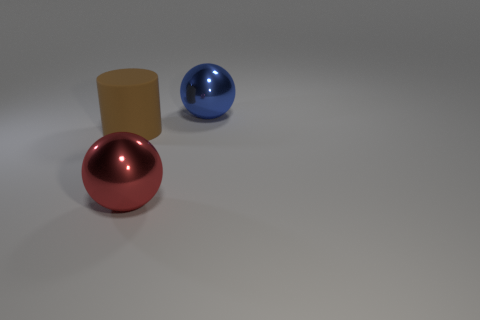Is there a rubber object of the same shape as the big blue metal object?
Give a very brief answer. No. What is the shape of the red metallic object that is the same size as the matte cylinder?
Offer a very short reply. Sphere. Is the number of large red shiny objects that are behind the big brown cylinder the same as the number of brown rubber things that are to the right of the big blue sphere?
Ensure brevity in your answer.  Yes. How big is the ball that is in front of the thing that is to the left of the red shiny sphere?
Ensure brevity in your answer.  Large. Is there a blue thing of the same size as the blue shiny ball?
Keep it short and to the point. No. What is the color of the thing that is the same material as the big blue ball?
Offer a very short reply. Red. Is the number of yellow matte blocks less than the number of big red balls?
Ensure brevity in your answer.  Yes. There is a big object that is in front of the big blue metal ball and to the right of the brown thing; what is its material?
Ensure brevity in your answer.  Metal. Are there any red things that are behind the ball that is in front of the brown thing?
Make the answer very short. No. Are the large red ball and the blue sphere made of the same material?
Keep it short and to the point. Yes. 